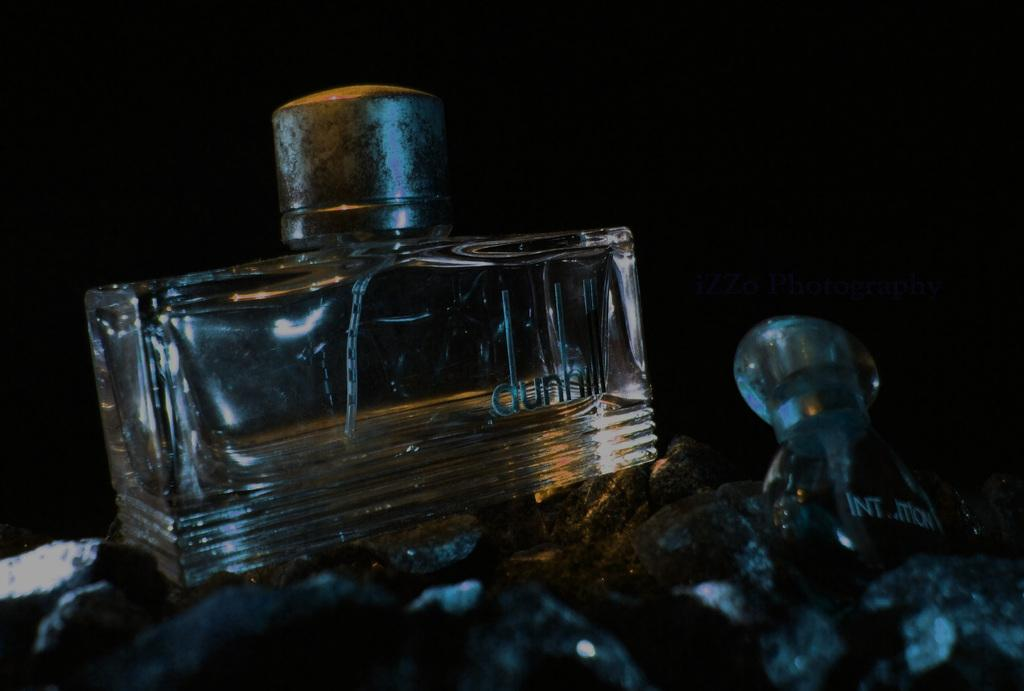What objects are present in the image? There are two perfume bottles and small stones in the image. What is the color of the background in the image? The background of the image is black. Where is the basketball located in the image? There is no basketball present in the image. What type of crowd can be seen in the image? There is no crowd present in the image. 